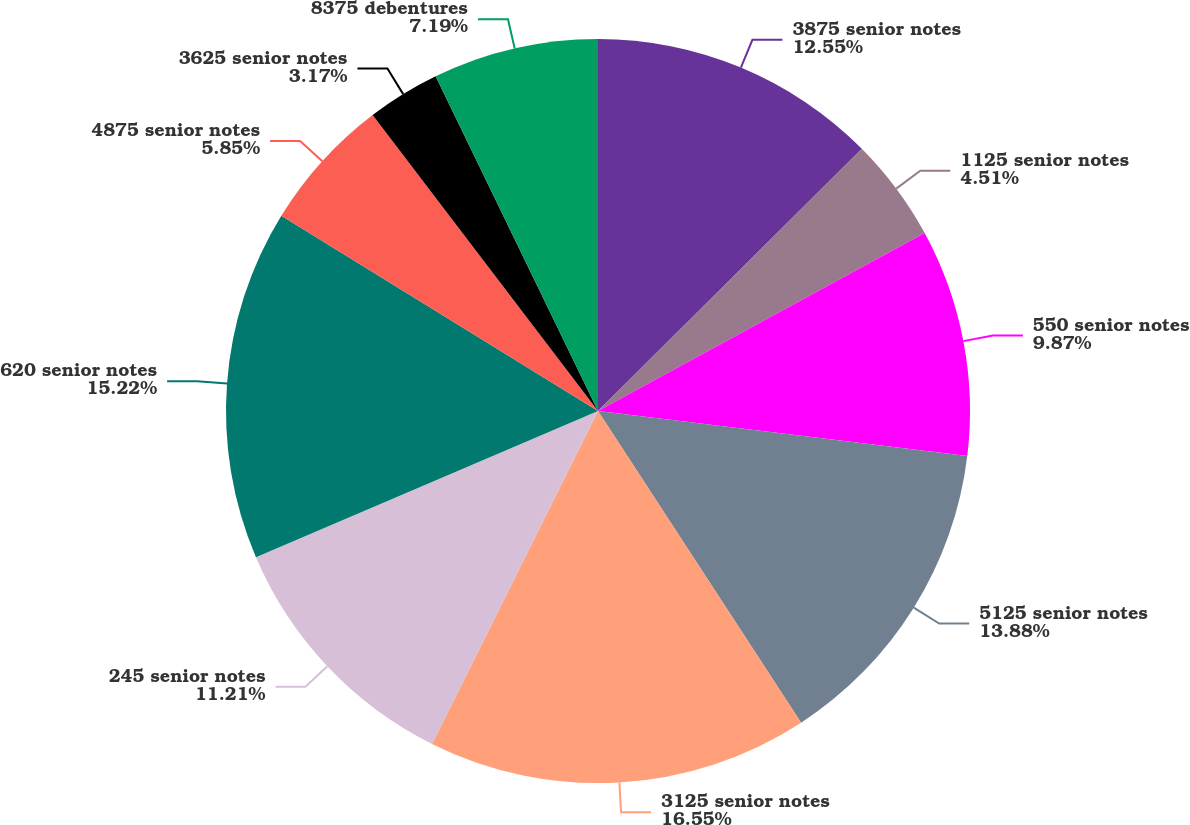Convert chart. <chart><loc_0><loc_0><loc_500><loc_500><pie_chart><fcel>3875 senior notes<fcel>1125 senior notes<fcel>550 senior notes<fcel>5125 senior notes<fcel>3125 senior notes<fcel>245 senior notes<fcel>620 senior notes<fcel>4875 senior notes<fcel>3625 senior notes<fcel>8375 debentures<nl><fcel>12.55%<fcel>4.51%<fcel>9.87%<fcel>13.88%<fcel>16.56%<fcel>11.21%<fcel>15.22%<fcel>5.85%<fcel>3.17%<fcel>7.19%<nl></chart> 